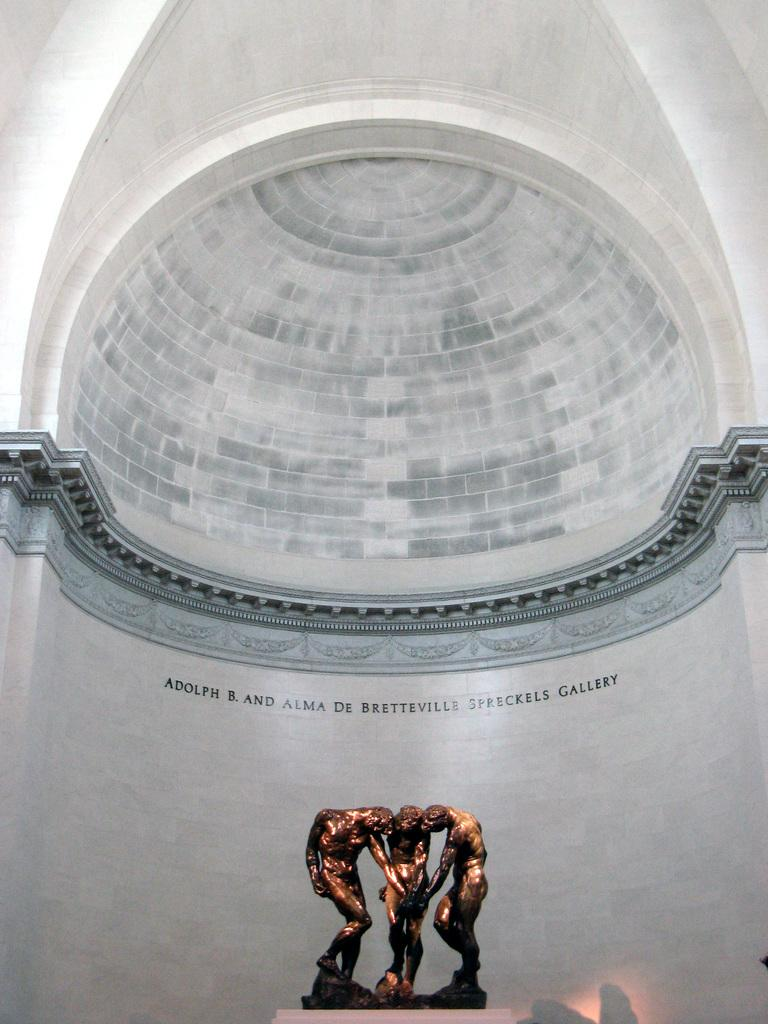What is located at the bottom of the image? There is a statue at the bottom of the image. What can be seen on the wall in the background of the image? There is text on the wall in the background of the image. What architectural feature is visible in the background of the image? There is a roof visible in the background of the image. What type of meat can be seen on the ground in the image? There is no meat present on the ground in the image. How does the taste of the statue compare to the text on the wall? The taste of the statue and the text on the wall cannot be compared, as neither has a taste. 